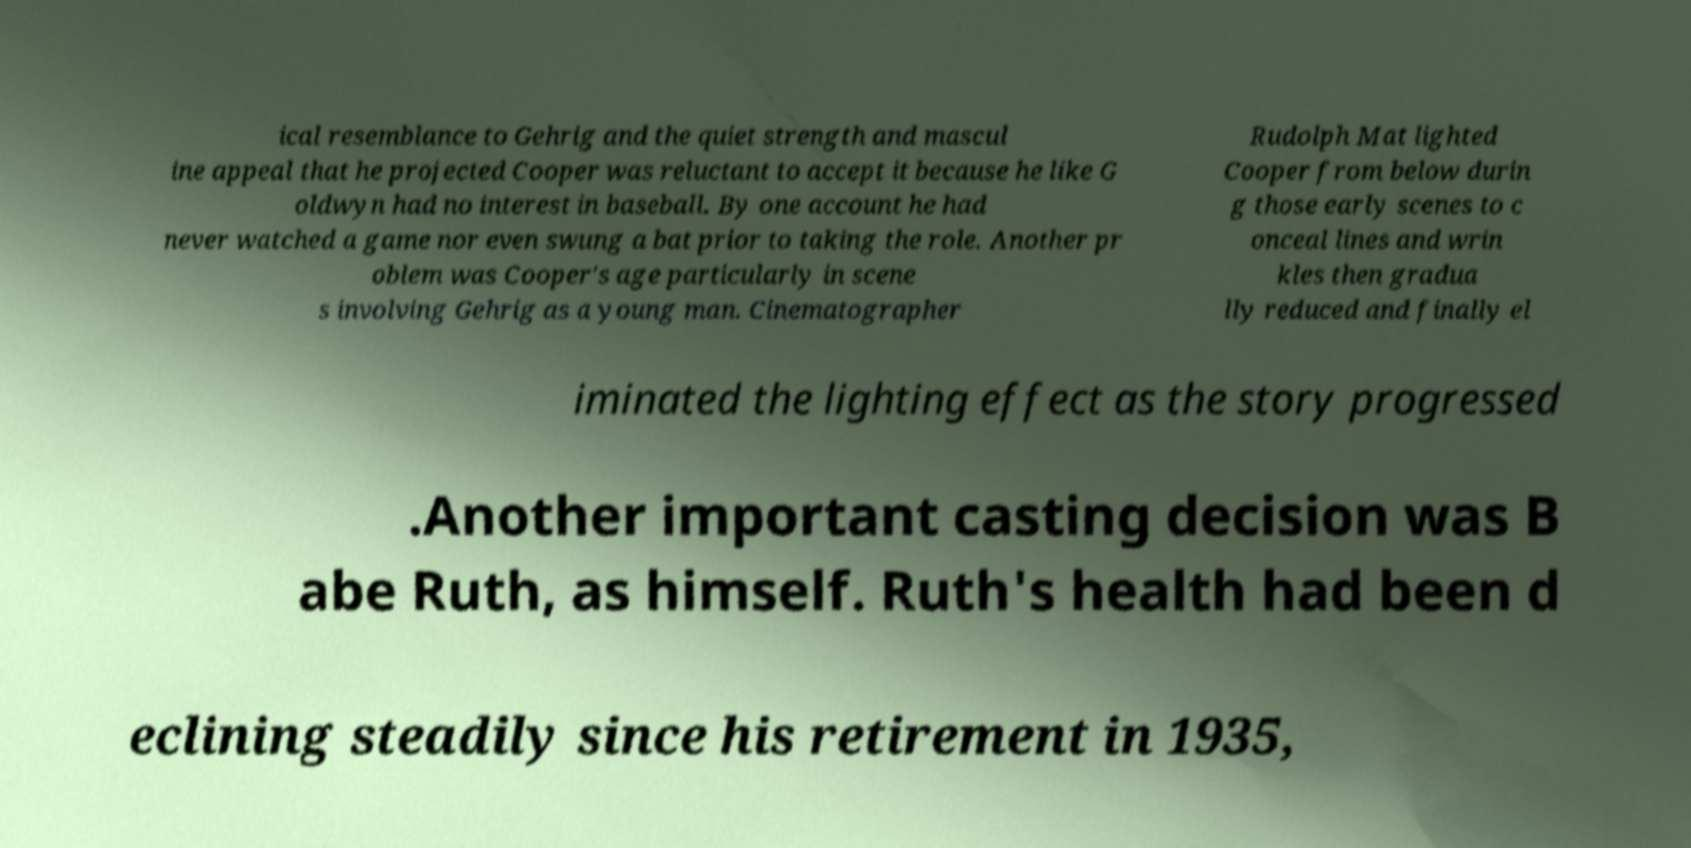There's text embedded in this image that I need extracted. Can you transcribe it verbatim? ical resemblance to Gehrig and the quiet strength and mascul ine appeal that he projected Cooper was reluctant to accept it because he like G oldwyn had no interest in baseball. By one account he had never watched a game nor even swung a bat prior to taking the role. Another pr oblem was Cooper's age particularly in scene s involving Gehrig as a young man. Cinematographer Rudolph Mat lighted Cooper from below durin g those early scenes to c onceal lines and wrin kles then gradua lly reduced and finally el iminated the lighting effect as the story progressed .Another important casting decision was B abe Ruth, as himself. Ruth's health had been d eclining steadily since his retirement in 1935, 